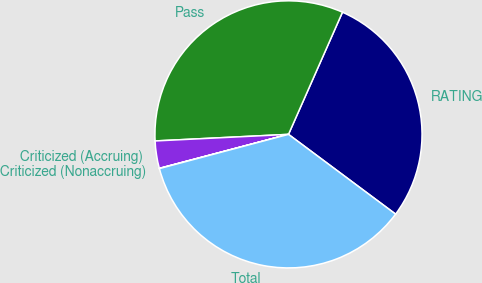Convert chart to OTSL. <chart><loc_0><loc_0><loc_500><loc_500><pie_chart><fcel>RATING<fcel>Pass<fcel>Criticized (Accruing)<fcel>Criticized (Nonaccruing)<fcel>Total<nl><fcel>28.57%<fcel>32.41%<fcel>3.31%<fcel>0.03%<fcel>35.69%<nl></chart> 